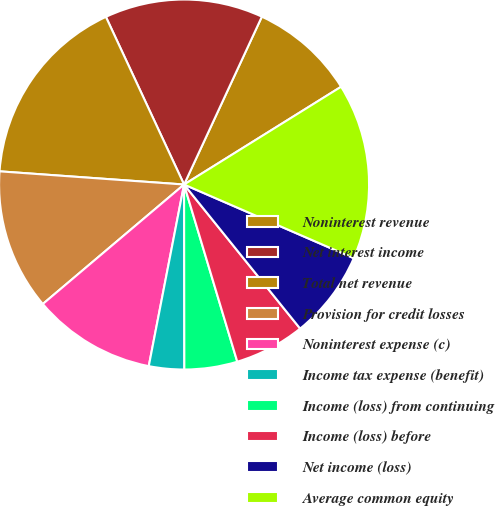Convert chart. <chart><loc_0><loc_0><loc_500><loc_500><pie_chart><fcel>Noninterest revenue<fcel>Net interest income<fcel>Total net revenue<fcel>Provision for credit losses<fcel>Noninterest expense (c)<fcel>Income tax expense (benefit)<fcel>Income (loss) from continuing<fcel>Income (loss) before<fcel>Net income (loss)<fcel>Average common equity<nl><fcel>9.23%<fcel>13.85%<fcel>16.92%<fcel>12.31%<fcel>10.77%<fcel>3.08%<fcel>4.62%<fcel>6.15%<fcel>7.69%<fcel>15.38%<nl></chart> 